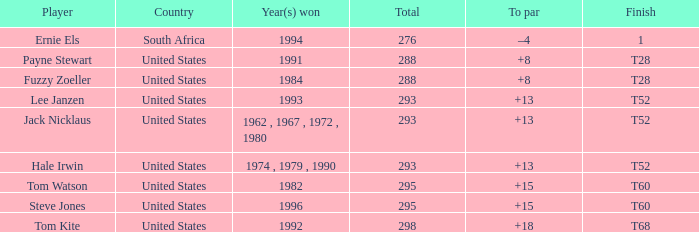What is the average total of player hale irwin, who had a t52 finish? 293.0. 